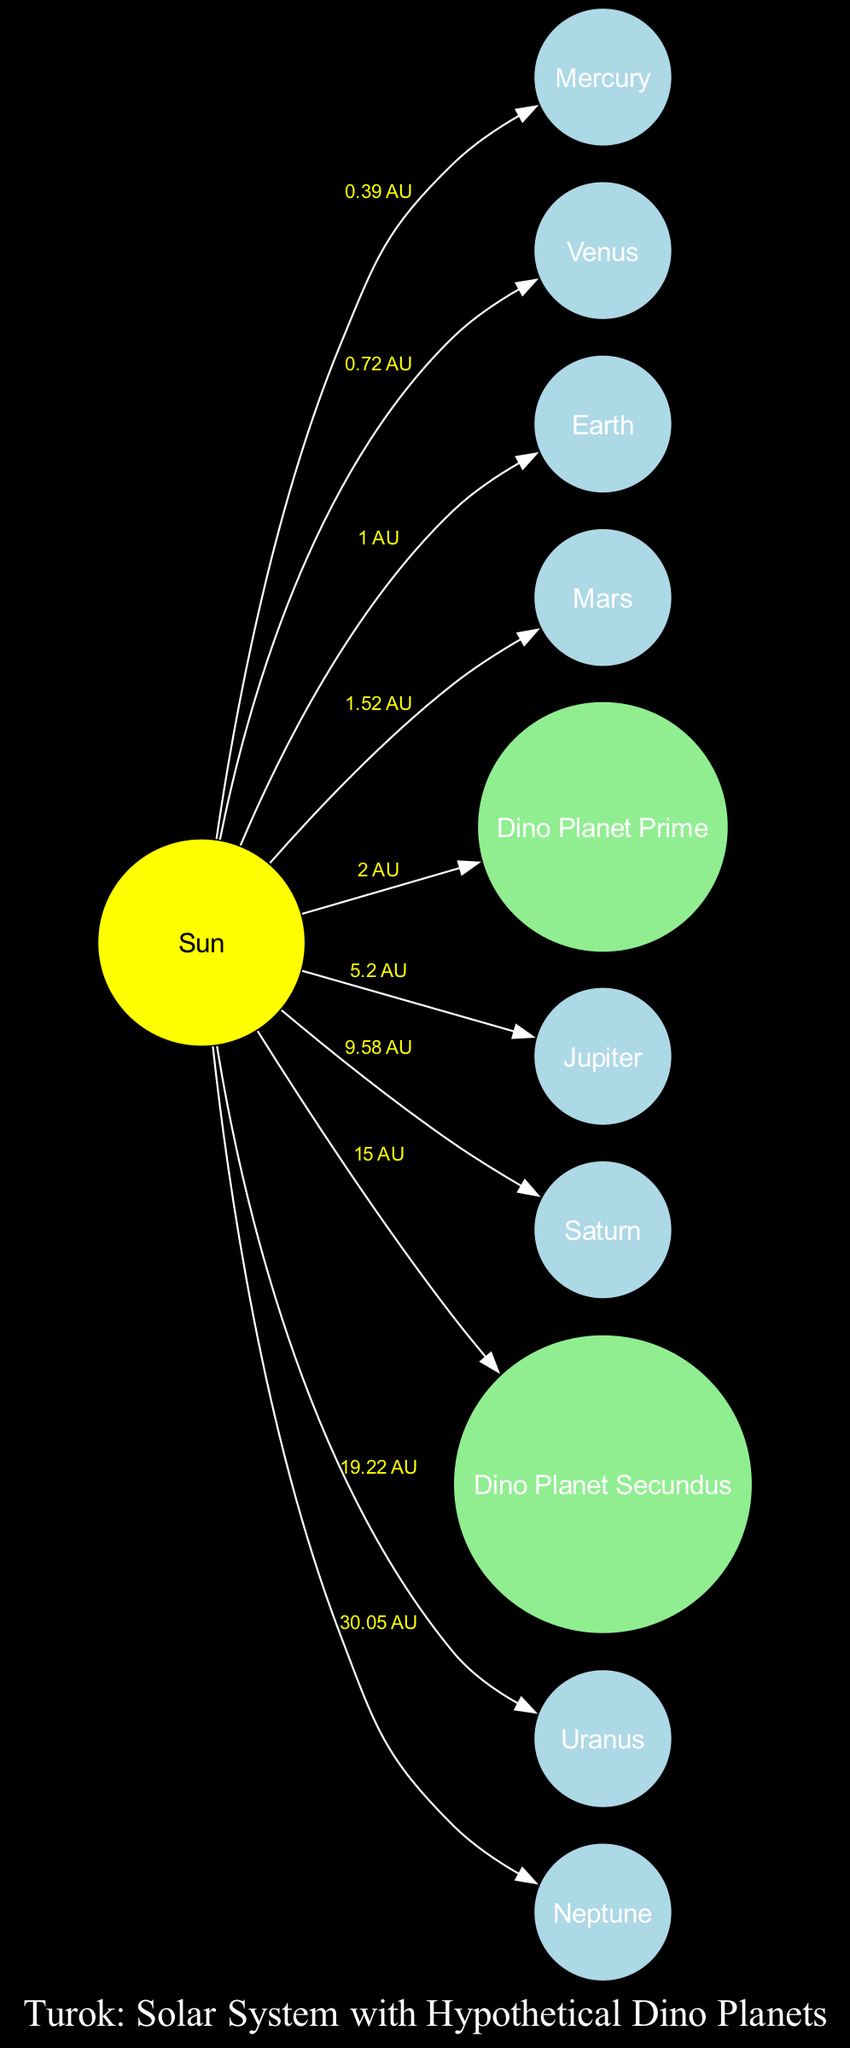What is the distance from the Sun to Earth? The diagram shows that Earth is connected to the Sun with a label indicating the distance. This label reads "1 AU," representing the distance from the Sun to Earth.
Answer: 1 AU Which planet is closest to the Sun? The diagram displays various planets and their distances from the Sun. The first planet listed and closest to the Sun, as shown by the label, is Mercury.
Answer: Mercury How many hypothetical dinosaur planets are there? By inspecting the nodes in the diagram, two hypothetical planets are identified: Dino Planet Prime and Dino Planet Secundus. Therefore, counting these gives the total.
Answer: 2 What is the distance from the Sun to Dino Planet Secundus? The diagram provides a direct edge from the Sun to Dino Planet Secundus, which is labeled with "15 AU." This indicates the distance from the Sun to this hypothetical planet.
Answer: 15 AU Which planet orbits at 9.58 AU from the Sun? The label on the edge from the Sun states "9.58 AU." By checking the corresponding node, which is connected to this edge, we find that it connects to Saturn.
Answer: Saturn What type of body is Dino Planet Prime? The diagram identifies different types of astronomical bodies. Dino Planet Prime is classified under the type "hypothetical_planet," as indicated in the nodes section of the data.
Answer: hypothetical_planet What is the farthest planet from the Sun listed in this diagram? By analyzing the distances of all planets from the Sun in the diagram, Neptune is observed to have the largest distance at "30.05 AU." Hence, it is the farthest.
Answer: Neptune How many planets are located between Mars and Jupiter in the diagram? The diagram lists the planets in order of their distance from the Sun. The planets explicitly between Mars and Jupiter are counted directly from the diagram, revealing there are none since Jupiter follows Mars immediately.
Answer: 0 Which planet has a distance of 0.72 AU from the Sun? Referring to the edge connecting the Sun to the planets, the label for Venus is listed as "0.72 AU." This piece of information confirms the distance for Venus accurately.
Answer: Venus 